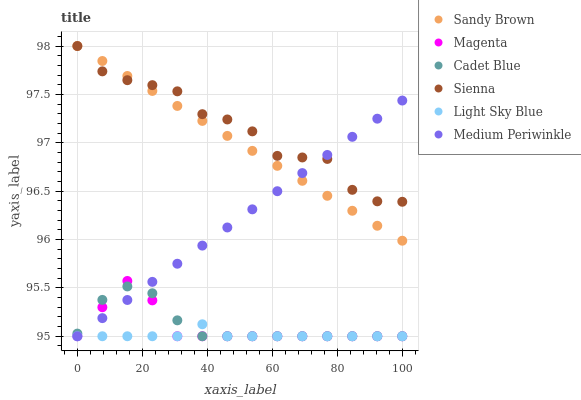Does Light Sky Blue have the minimum area under the curve?
Answer yes or no. Yes. Does Sienna have the maximum area under the curve?
Answer yes or no. Yes. Does Medium Periwinkle have the minimum area under the curve?
Answer yes or no. No. Does Medium Periwinkle have the maximum area under the curve?
Answer yes or no. No. Is Medium Periwinkle the smoothest?
Answer yes or no. Yes. Is Sienna the roughest?
Answer yes or no. Yes. Is Sienna the smoothest?
Answer yes or no. No. Is Medium Periwinkle the roughest?
Answer yes or no. No. Does Cadet Blue have the lowest value?
Answer yes or no. Yes. Does Sienna have the lowest value?
Answer yes or no. No. Does Sandy Brown have the highest value?
Answer yes or no. Yes. Does Medium Periwinkle have the highest value?
Answer yes or no. No. Is Magenta less than Sienna?
Answer yes or no. Yes. Is Sandy Brown greater than Light Sky Blue?
Answer yes or no. Yes. Does Medium Periwinkle intersect Sienna?
Answer yes or no. Yes. Is Medium Periwinkle less than Sienna?
Answer yes or no. No. Is Medium Periwinkle greater than Sienna?
Answer yes or no. No. Does Magenta intersect Sienna?
Answer yes or no. No. 